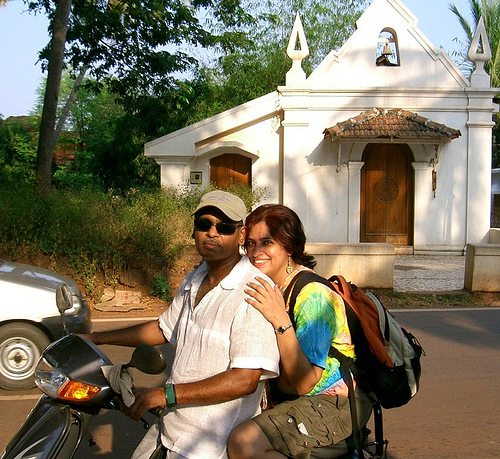Can you tell me more about the location they might be at? The setting appears to be in a warm climate, given the sunny weather and the verdant surroundings. The building in the background has characteristics of traditional architecture, which might indicate a historic area or a place of cultural significance. The presence of a car implies that this is a road used by vehicles, possibly on the outskirts of a town or in a semi-urban area. 